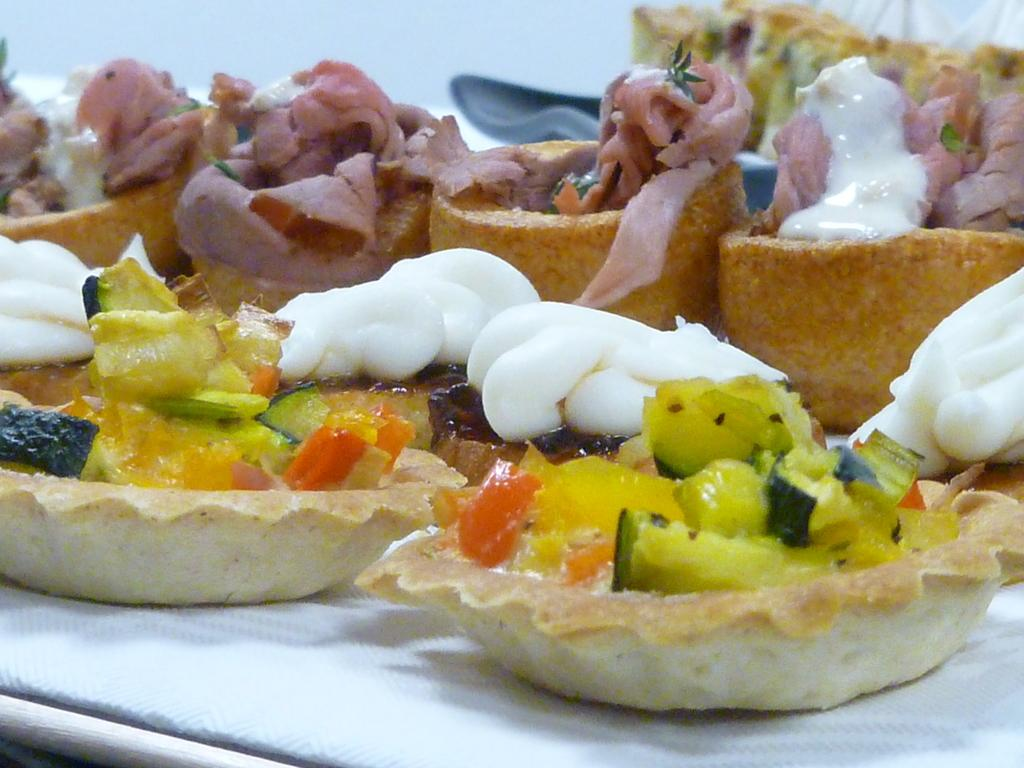What can be seen in the image? There are different types of food in the image. Where is the food located? The food is placed on a table. What type of skirt is being worn by the food in the image? There is no skirt present in the image, as the subject is food and not a person wearing clothing. 